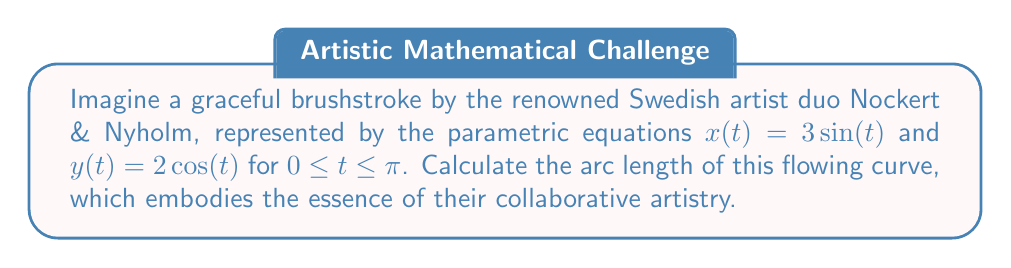Give your solution to this math problem. To determine the arc length of a parametric curve, we use the formula:

$$L = \int_{a}^{b} \sqrt{\left(\frac{dx}{dt}\right)^2 + \left(\frac{dy}{dt}\right)^2} dt$$

where $a$ and $b$ are the lower and upper bounds of the parameter $t$.

Step 1: Find $\frac{dx}{dt}$ and $\frac{dy}{dt}$
$\frac{dx}{dt} = 3\cos(t)$
$\frac{dy}{dt} = -2\sin(t)$

Step 2: Substitute into the arc length formula
$$L = \int_{0}^{\pi} \sqrt{(3\cos(t))^2 + (-2\sin(t))^2} dt$$

Step 3: Simplify under the square root
$$L = \int_{0}^{\pi} \sqrt{9\cos^2(t) + 4\sin^2(t)} dt$$

Step 4: Use the trigonometric identity $\cos^2(t) + \sin^2(t) = 1$
$$L = \int_{0}^{\pi} \sqrt{9(\cos^2(t) + \sin^2(t)) - 5\sin^2(t)} dt$$
$$L = \int_{0}^{\pi} \sqrt{9 - 5\sin^2(t)} dt$$

Step 5: Let $u = \sin(t)$, then $du = \cos(t)dt$
$$L = \int_{0}^{1} \sqrt{9 - 5u^2} \frac{du}{\sqrt{1-u^2}}$$

Step 6: This integral can be evaluated using elliptic integrals, specifically the complete elliptic integral of the second kind:
$$L = 3E\left(\sqrt{\frac{5}{9}}\right)$$

Where $E(k)$ is the complete elliptic integral of the second kind with modulus $k$.
Answer: The arc length of the parametric curve is $3E\left(\sqrt{\frac{5}{9}}\right)$, where $E$ is the complete elliptic integral of the second kind. 